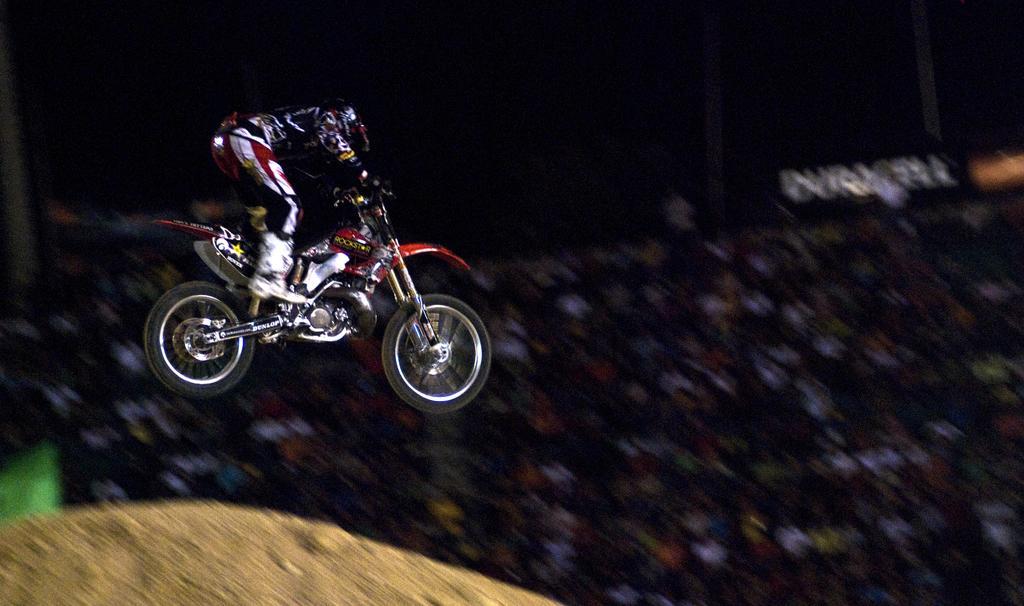Describe this image in one or two sentences. Here, we can see a person riding a bike, in the background there are some people sitting. 